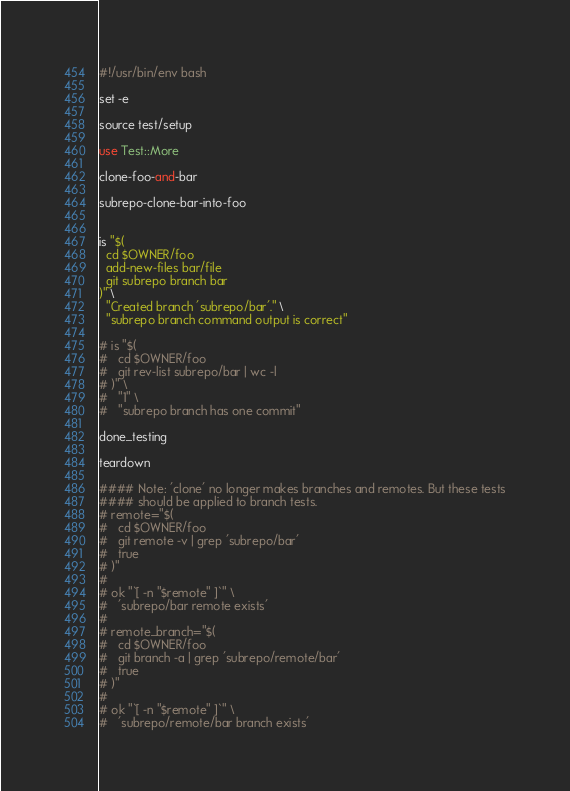<code> <loc_0><loc_0><loc_500><loc_500><_Perl_>#!/usr/bin/env bash

set -e

source test/setup

use Test::More

clone-foo-and-bar

subrepo-clone-bar-into-foo


is "$(
  cd $OWNER/foo
  add-new-files bar/file
  git subrepo branch bar
)" \
  "Created branch 'subrepo/bar'." \
  "subrepo branch command output is correct"

# is "$(
#   cd $OWNER/foo
#   git rev-list subrepo/bar | wc -l
# )" \
#   "1" \
#   "subrepo branch has one commit"

done_testing

teardown

#### Note: 'clone' no longer makes branches and remotes. But these tests
#### should be applied to branch tests.
# remote="$(
#   cd $OWNER/foo
#   git remote -v | grep 'subrepo/bar'
#   true
# )"
# 
# ok "`[ -n "$remote" ]`" \
#   'subrepo/bar remote exists'
# 
# remote_branch="$(
#   cd $OWNER/foo
#   git branch -a | grep 'subrepo/remote/bar'
#   true
# )"
# 
# ok "`[ -n "$remote" ]`" \
#   'subrepo/remote/bar branch exists'

</code> 